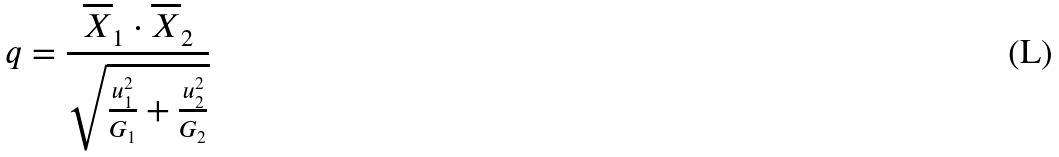Convert formula to latex. <formula><loc_0><loc_0><loc_500><loc_500>q = \frac { \overline { X } _ { 1 } \cdot \overline { X } _ { 2 } } { \sqrt { \frac { u _ { 1 } ^ { 2 } } { G _ { 1 } } + \frac { u _ { 2 } ^ { 2 } } { G _ { 2 } } } }</formula> 